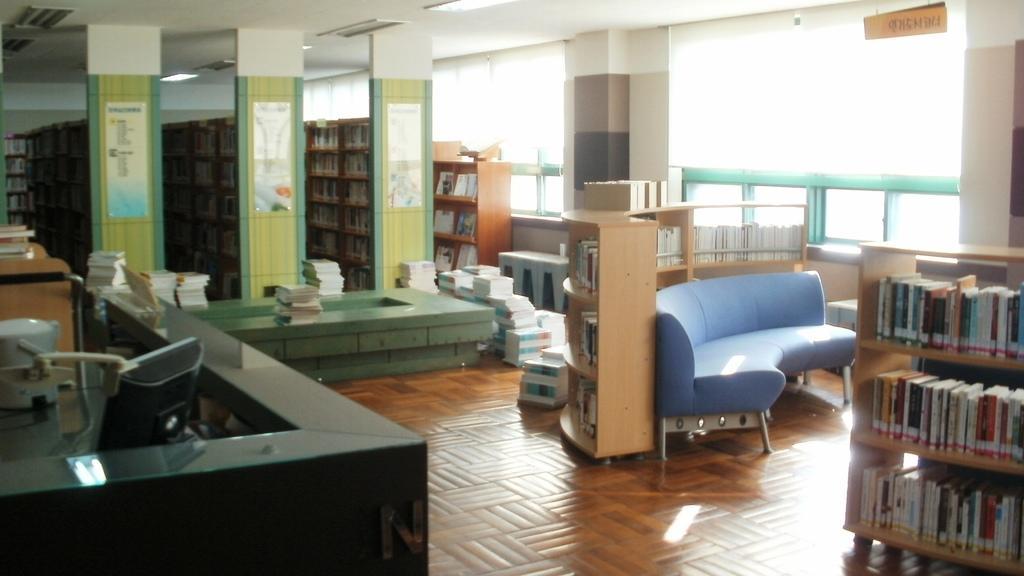Describe this image in one or two sentences. This picture shows a library with books arranged in the shelf, there is a couch over here and there is a help desk on to the left which has a monitor and some other objects and there are some books kept on the floor there are some ceiling lights attached and on the right there is a window 